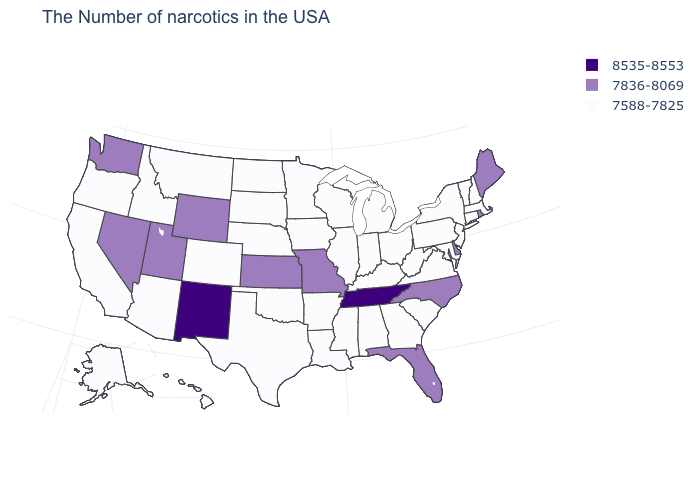What is the highest value in the USA?
Be succinct. 8535-8553. Is the legend a continuous bar?
Answer briefly. No. What is the value of Pennsylvania?
Give a very brief answer. 7588-7825. What is the lowest value in the USA?
Keep it brief. 7588-7825. What is the lowest value in the USA?
Be succinct. 7588-7825. Which states hav the highest value in the South?
Answer briefly. Tennessee. Is the legend a continuous bar?
Keep it brief. No. Name the states that have a value in the range 7588-7825?
Answer briefly. Massachusetts, New Hampshire, Vermont, Connecticut, New York, New Jersey, Maryland, Pennsylvania, Virginia, South Carolina, West Virginia, Ohio, Georgia, Michigan, Kentucky, Indiana, Alabama, Wisconsin, Illinois, Mississippi, Louisiana, Arkansas, Minnesota, Iowa, Nebraska, Oklahoma, Texas, South Dakota, North Dakota, Colorado, Montana, Arizona, Idaho, California, Oregon, Alaska, Hawaii. How many symbols are there in the legend?
Quick response, please. 3. What is the value of Indiana?
Answer briefly. 7588-7825. Name the states that have a value in the range 8535-8553?
Keep it brief. Tennessee, New Mexico. Does Vermont have the lowest value in the Northeast?
Write a very short answer. Yes. Name the states that have a value in the range 8535-8553?
Give a very brief answer. Tennessee, New Mexico. How many symbols are there in the legend?
Be succinct. 3. 